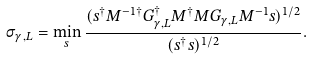<formula> <loc_0><loc_0><loc_500><loc_500>\sigma _ { \gamma , L } = \min _ { s } \frac { ( s ^ { \dagger } M ^ { - 1 \dagger } G _ { \gamma , L } ^ { \dagger } M ^ { \dagger } M G _ { \gamma , L } M ^ { - 1 } s ) ^ { 1 / 2 } } { ( s ^ { \dagger } s ) ^ { 1 / 2 } } .</formula> 